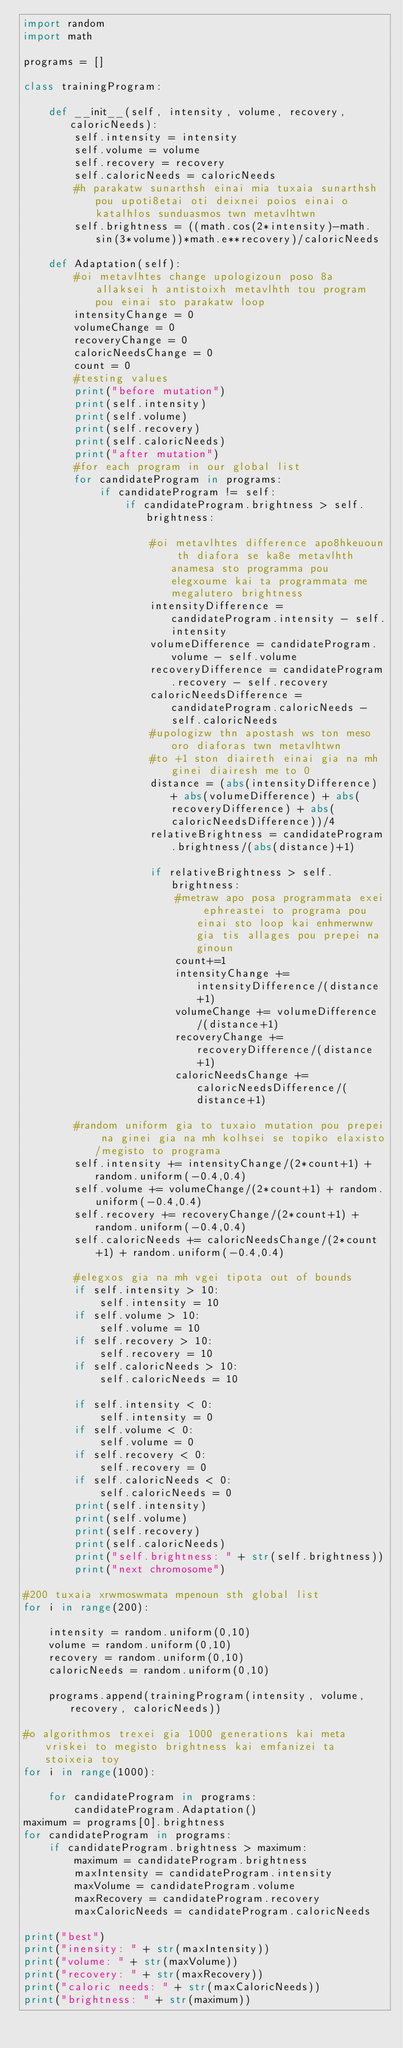Convert code to text. <code><loc_0><loc_0><loc_500><loc_500><_Python_>import random
import math

programs = []

class trainingProgram:
	
	def __init__(self, intensity, volume, recovery, caloricNeeds):
		self.intensity = intensity
		self.volume = volume
		self.recovery = recovery
		self.caloricNeeds = caloricNeeds
		#h parakatw sunarthsh einai mia tuxaia sunarthsh pou upoti8etai oti deixnei poios einai o katalhlos sunduasmos twn metavlhtwn
		self.brightness = ((math.cos(2*intensity)-math.sin(3*volume))*math.e**recovery)/caloricNeeds
		
	def Adaptation(self):
		#oi metavlhtes change upologizoun poso 8a allaksei h antistoixh metavlhth tou program pou einai sto parakatw loop
		intensityChange = 0
		volumeChange = 0
		recoveryChange = 0
		caloricNeedsChange = 0
		count = 0
		#testing values
		print("before mutation")
		print(self.intensity)
		print(self.volume)
		print(self.recovery)
		print(self.caloricNeeds)
		print("after mutation")
		#for each program in our global list
		for candidateProgram in programs:
			if candidateProgram != self:
				if candidateProgram.brightness > self.brightness:

					#oi metavlhtes difference apo8hkeuoun th diafora se ka8e metavlhth anamesa sto programma pou elegxoume kai ta programmata me megalutero brightness
					intensityDifference = candidateProgram.intensity - self.intensity
					volumeDifference = candidateProgram.volume - self.volume
					recoveryDifference = candidateProgram.recovery - self.recovery
					caloricNeedsDifference = candidateProgram.caloricNeeds - self.caloricNeeds
					#upologizw thn apostash ws ton meso oro diaforas twn metavlhtwn
					#to +1 ston diaireth einai gia na mh ginei diairesh me to 0
					distance = (abs(intensityDifference) + abs(volumeDifference) + abs(recoveryDifference) + abs(caloricNeedsDifference))/4
					relativeBrightness = candidateProgram.brightness/(abs(distance)+1)
					
					if relativeBrightness > self.brightness:
						#metraw apo posa programmata exei ephreastei to programa pou einai sto loop kai enhmerwnw gia tis allages pou prepei na ginoun
						count+=1
						intensityChange += intensityDifference/(distance+1)
						volumeChange += volumeDifference/(distance+1)
						recoveryChange += recoveryDifference/(distance+1)
						caloricNeedsChange += caloricNeedsDifference/(distance+1)
		
		#random uniform gia to tuxaio mutation pou prepei na ginei gia na mh kolhsei se topiko elaxisto/megisto to programa
		self.intensity += intensityChange/(2*count+1) + random.uniform(-0.4,0.4)
		self.volume += volumeChange/(2*count+1) + random.uniform(-0.4,0.4)
		self.recovery += recoveryChange/(2*count+1) + random.uniform(-0.4,0.4)
		self.caloricNeeds += caloricNeedsChange/(2*count+1) + random.uniform(-0.4,0.4)
		
		#elegxos gia na mh vgei tipota out of bounds
		if self.intensity > 10:
			self.intensity = 10
		if self.volume > 10:
			self.volume = 10
		if self.recovery > 10:
			self.recovery = 10
		if self.caloricNeeds > 10:
			self.caloricNeeds = 10
			
		if self.intensity < 0:
			self.intensity = 0
		if self.volume < 0:
			self.volume = 0
		if self.recovery < 0:
			self.recovery = 0
		if self.caloricNeeds < 0:
			self.caloricNeeds = 0
		print(self.intensity)
		print(self.volume)
		print(self.recovery)
		print(self.caloricNeeds)
		print("self.brightness: " + str(self.brightness))
		print("next chromosome")

#200 tuxaia xrwmoswmata mpenoun sth global list
for i in range(200):
	
	intensity = random.uniform(0,10)
	volume = random.uniform(0,10)
	recovery = random.uniform(0,10)
	caloricNeeds = random.uniform(0,10)
	
	programs.append(trainingProgram(intensity, volume, recovery, caloricNeeds))
	
#o algorithmos trexei gia 1000 generations kai meta vriskei to megisto brightness kai emfanizei ta stoixeia toy
for i in range(1000):
	
	for candidateProgram in programs:		
		candidateProgram.Adaptation()
maximum = programs[0].brightness
for candidateProgram in programs:
	if candidateProgram.brightness > maximum:
		maximum = candidateProgram.brightness
		maxIntensity = candidateProgram.intensity
		maxVolume = candidateProgram.volume
		maxRecovery = candidateProgram.recovery
		maxCaloricNeeds = candidateProgram.caloricNeeds

print("best")
print("inensity: " + str(maxIntensity))
print("volume: " + str(maxVolume))
print("recovery: " + str(maxRecovery))
print("caloric needs: " + str(maxCaloricNeeds))
print("brightness: " + str(maximum))</code> 